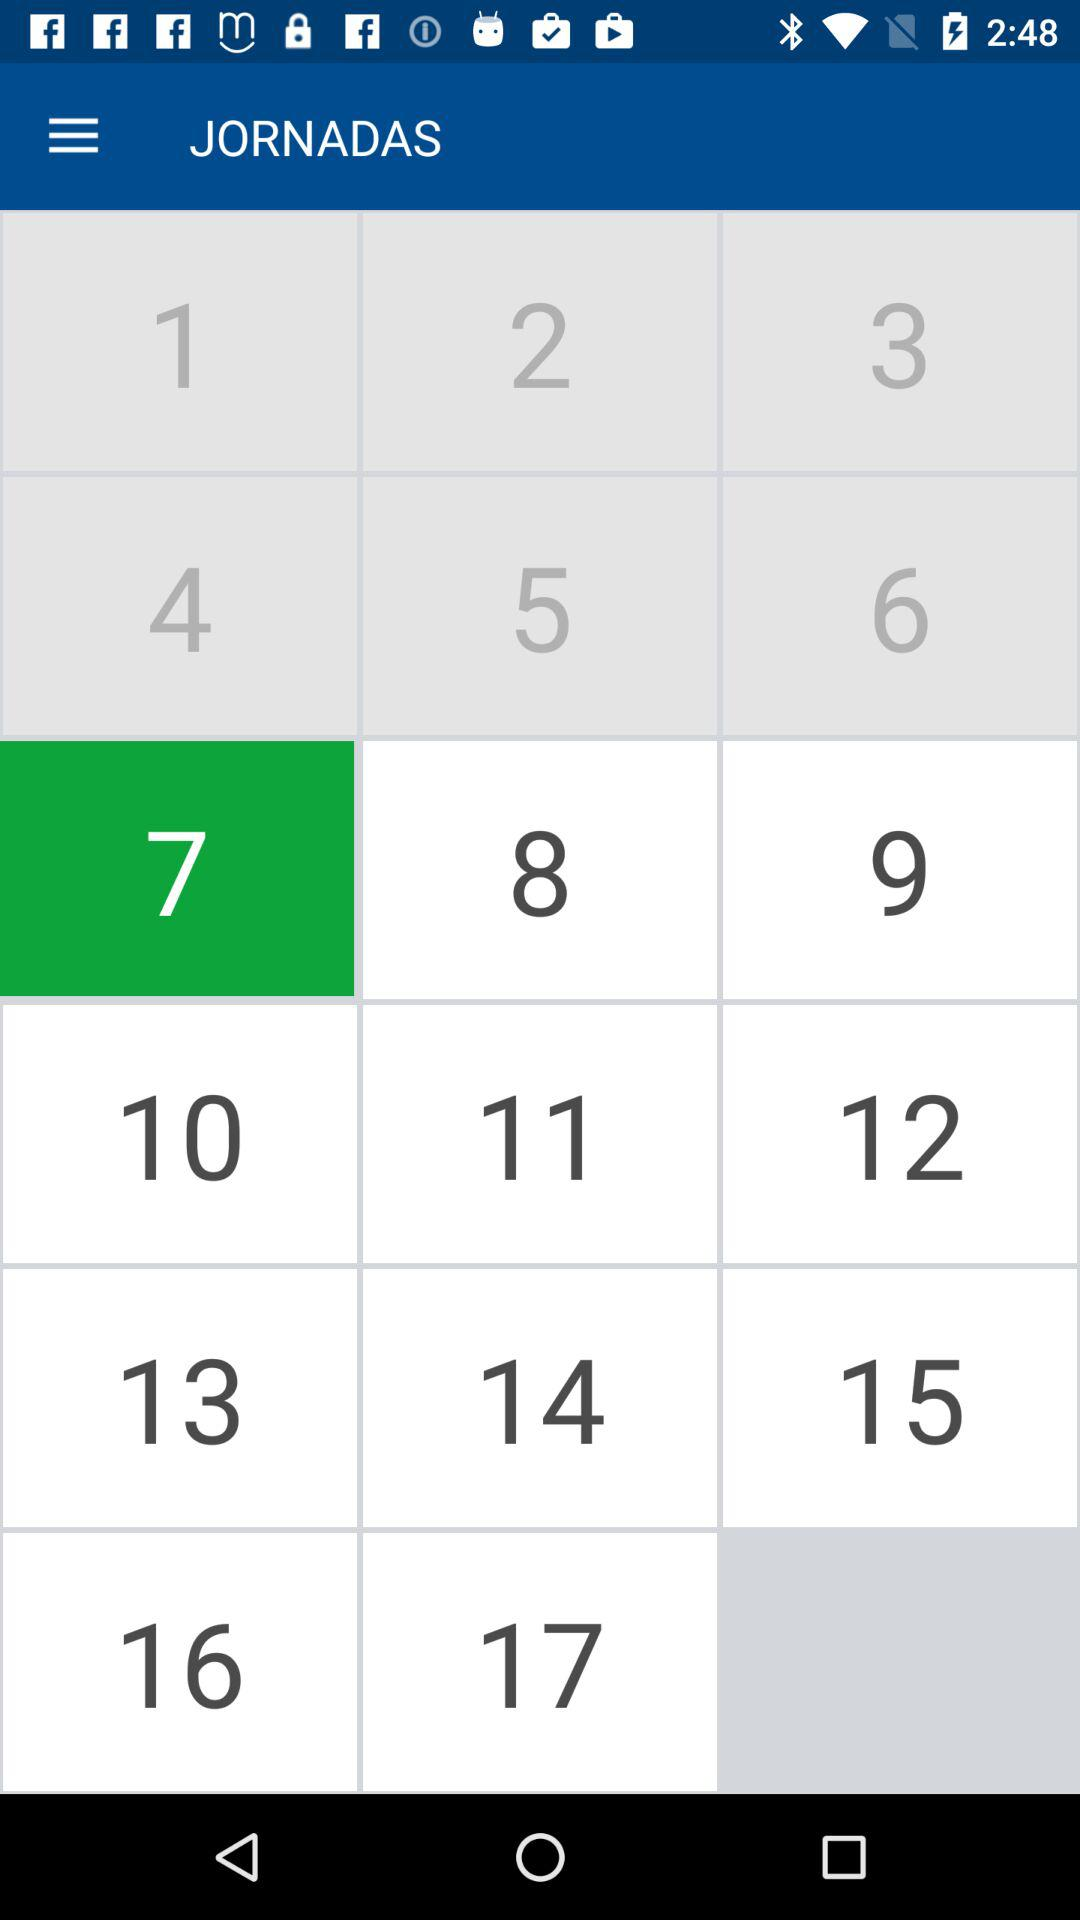Which number is the user on? The user is on number 7. 